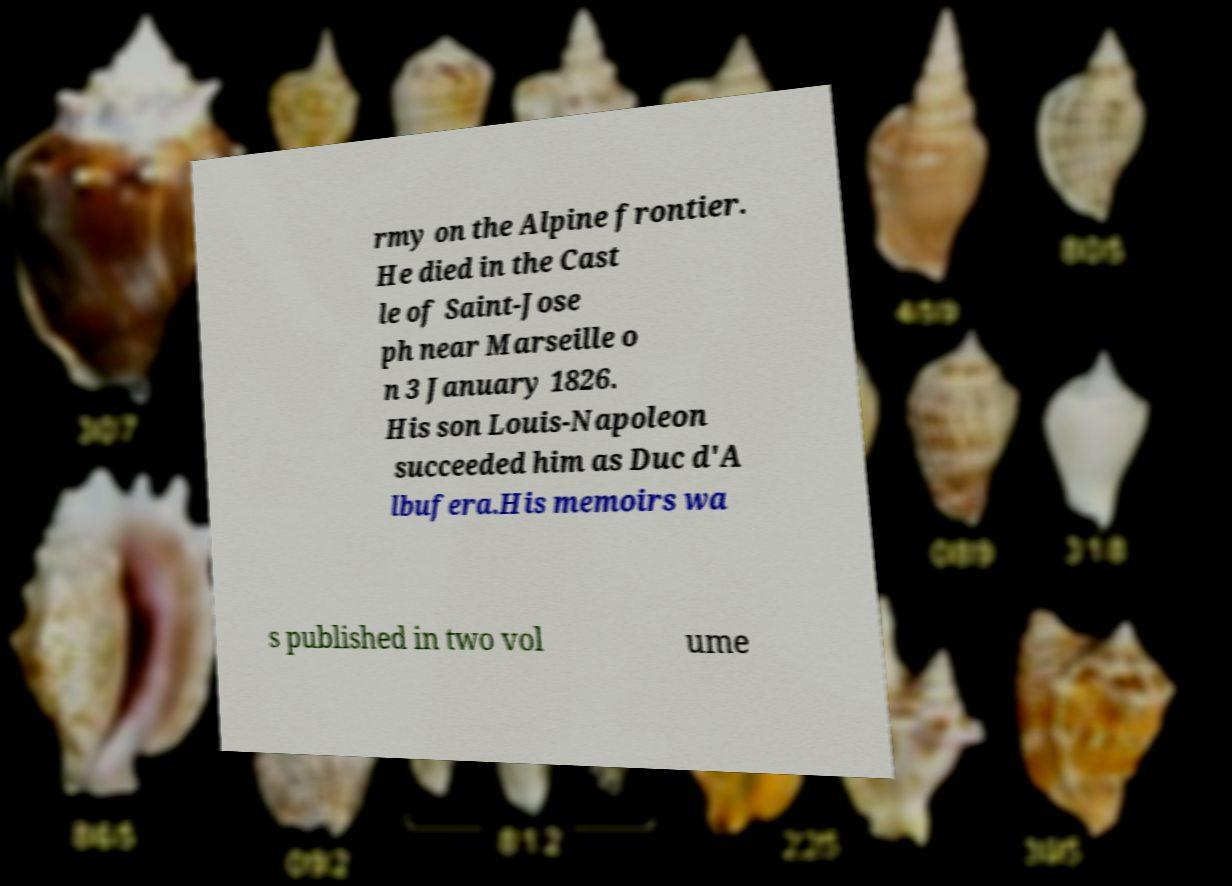Please read and relay the text visible in this image. What does it say? rmy on the Alpine frontier. He died in the Cast le of Saint-Jose ph near Marseille o n 3 January 1826. His son Louis-Napoleon succeeded him as Duc d'A lbufera.His memoirs wa s published in two vol ume 